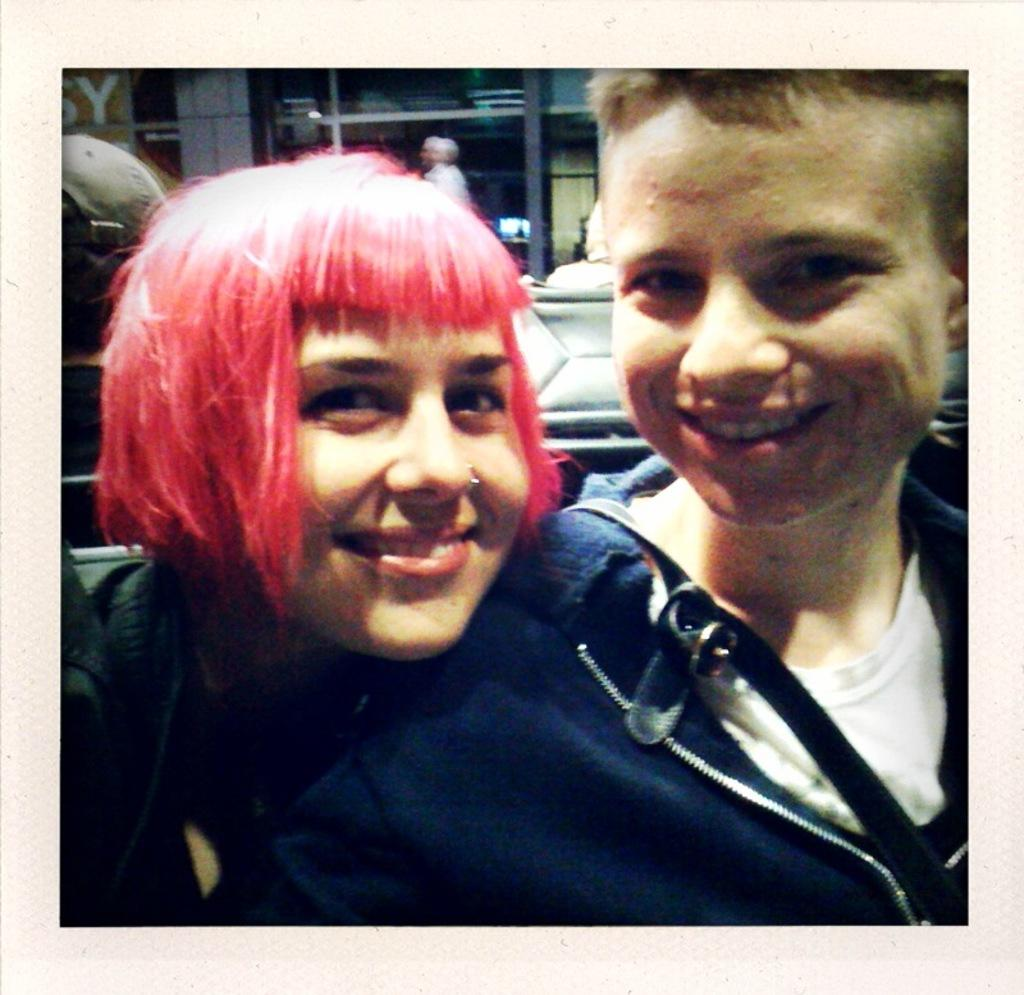How many people are present in the image? There are two people in the image. What expressions do the two people have? The two people are smiling. Can you describe the background of the image? There are people visible in the background of the image. What type of heart-shaped object can be seen in the image? There is no heart-shaped object present in the image. Can you tell me how many snails are visible in the image? There are no snails visible in the image. What type of vehicle is parked in the background of the image? There is no vehicle, such as a van, present in the image. 